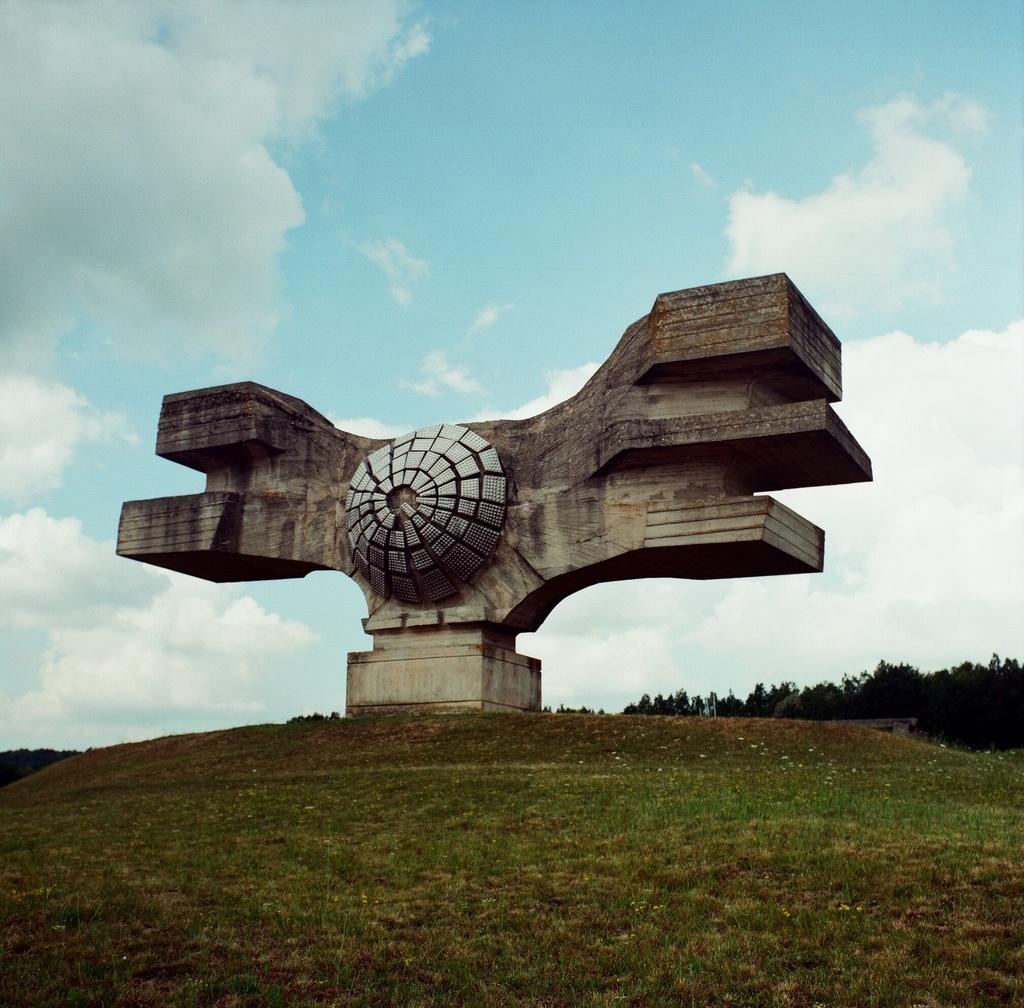What type of structure can be seen in the image? There is an arch in the image. What is the ground like in the image? The ground is covered in greenery. What can be seen in the background of the image? There are trees in the background of the image. What is visible in the sky in the image? The sky is visible and has clouds. Are there any pets visible in the image? There is no pet present in the image. What type of farm can be seen in the background of the image? There is no farm visible in the image; it features an arch, greenery, trees, and a cloudy sky. 